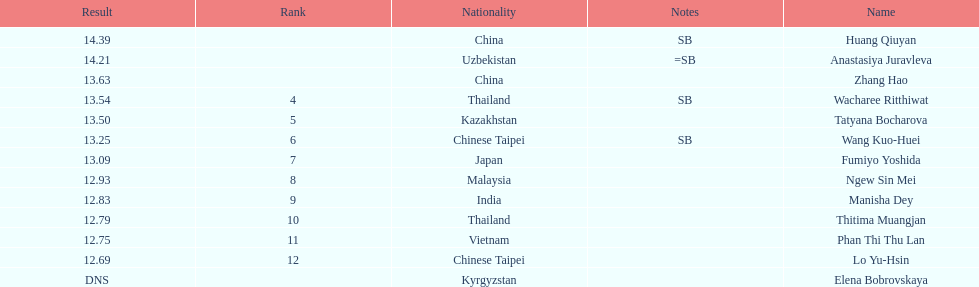How many athletes were from china? 2. 